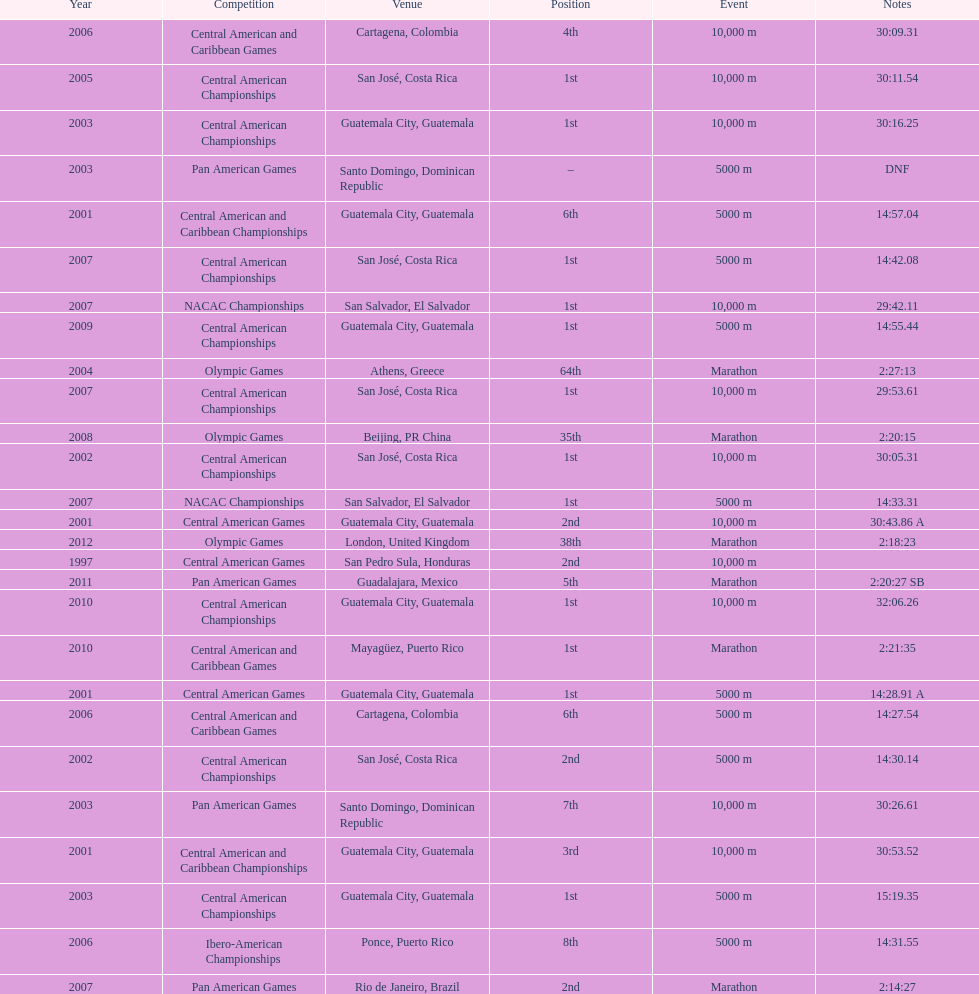How frequently has the 1st position been accomplished? 12. 